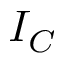Convert formula to latex. <formula><loc_0><loc_0><loc_500><loc_500>I _ { C }</formula> 